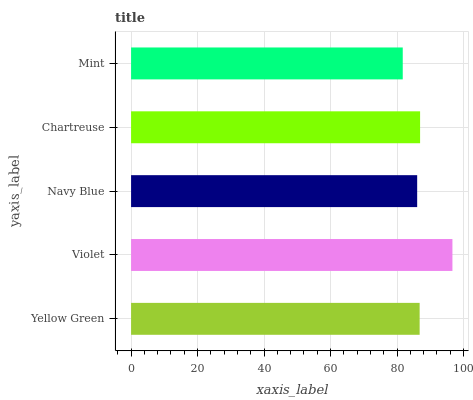Is Mint the minimum?
Answer yes or no. Yes. Is Violet the maximum?
Answer yes or no. Yes. Is Navy Blue the minimum?
Answer yes or no. No. Is Navy Blue the maximum?
Answer yes or no. No. Is Violet greater than Navy Blue?
Answer yes or no. Yes. Is Navy Blue less than Violet?
Answer yes or no. Yes. Is Navy Blue greater than Violet?
Answer yes or no. No. Is Violet less than Navy Blue?
Answer yes or no. No. Is Yellow Green the high median?
Answer yes or no. Yes. Is Yellow Green the low median?
Answer yes or no. Yes. Is Mint the high median?
Answer yes or no. No. Is Mint the low median?
Answer yes or no. No. 